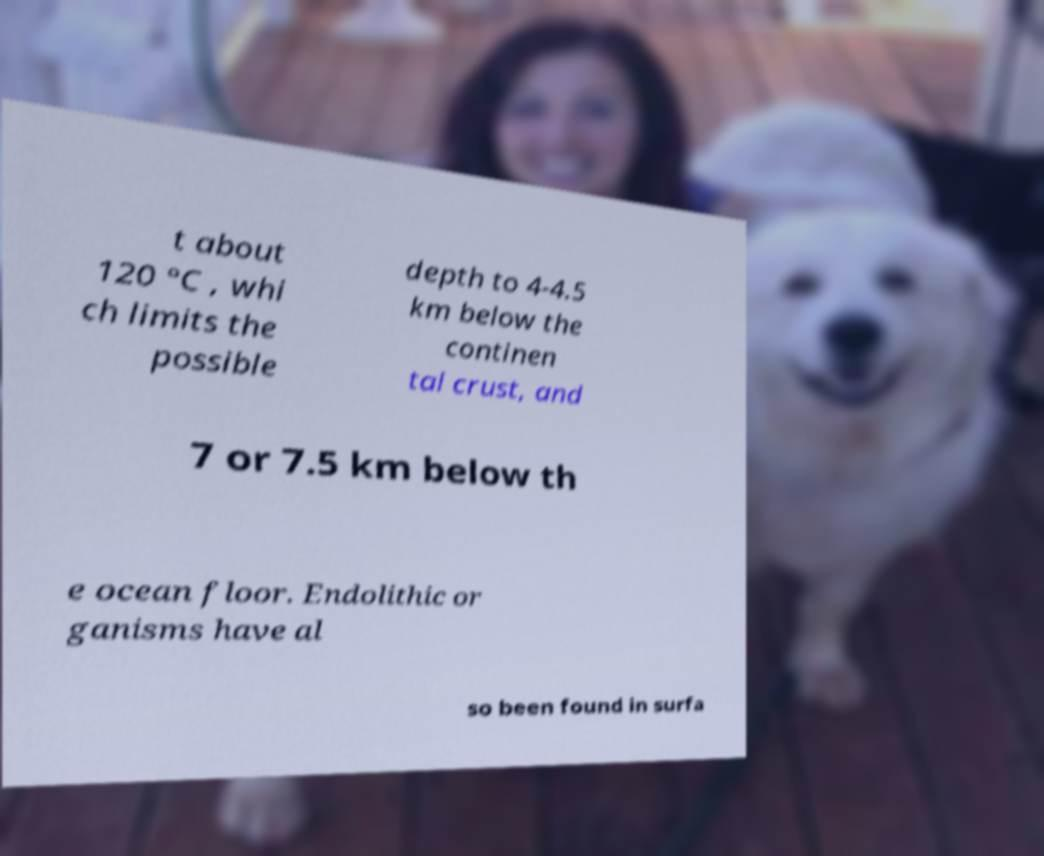For documentation purposes, I need the text within this image transcribed. Could you provide that? t about 120 °C , whi ch limits the possible depth to 4-4.5 km below the continen tal crust, and 7 or 7.5 km below th e ocean floor. Endolithic or ganisms have al so been found in surfa 